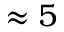Convert formula to latex. <formula><loc_0><loc_0><loc_500><loc_500>\approx 5</formula> 